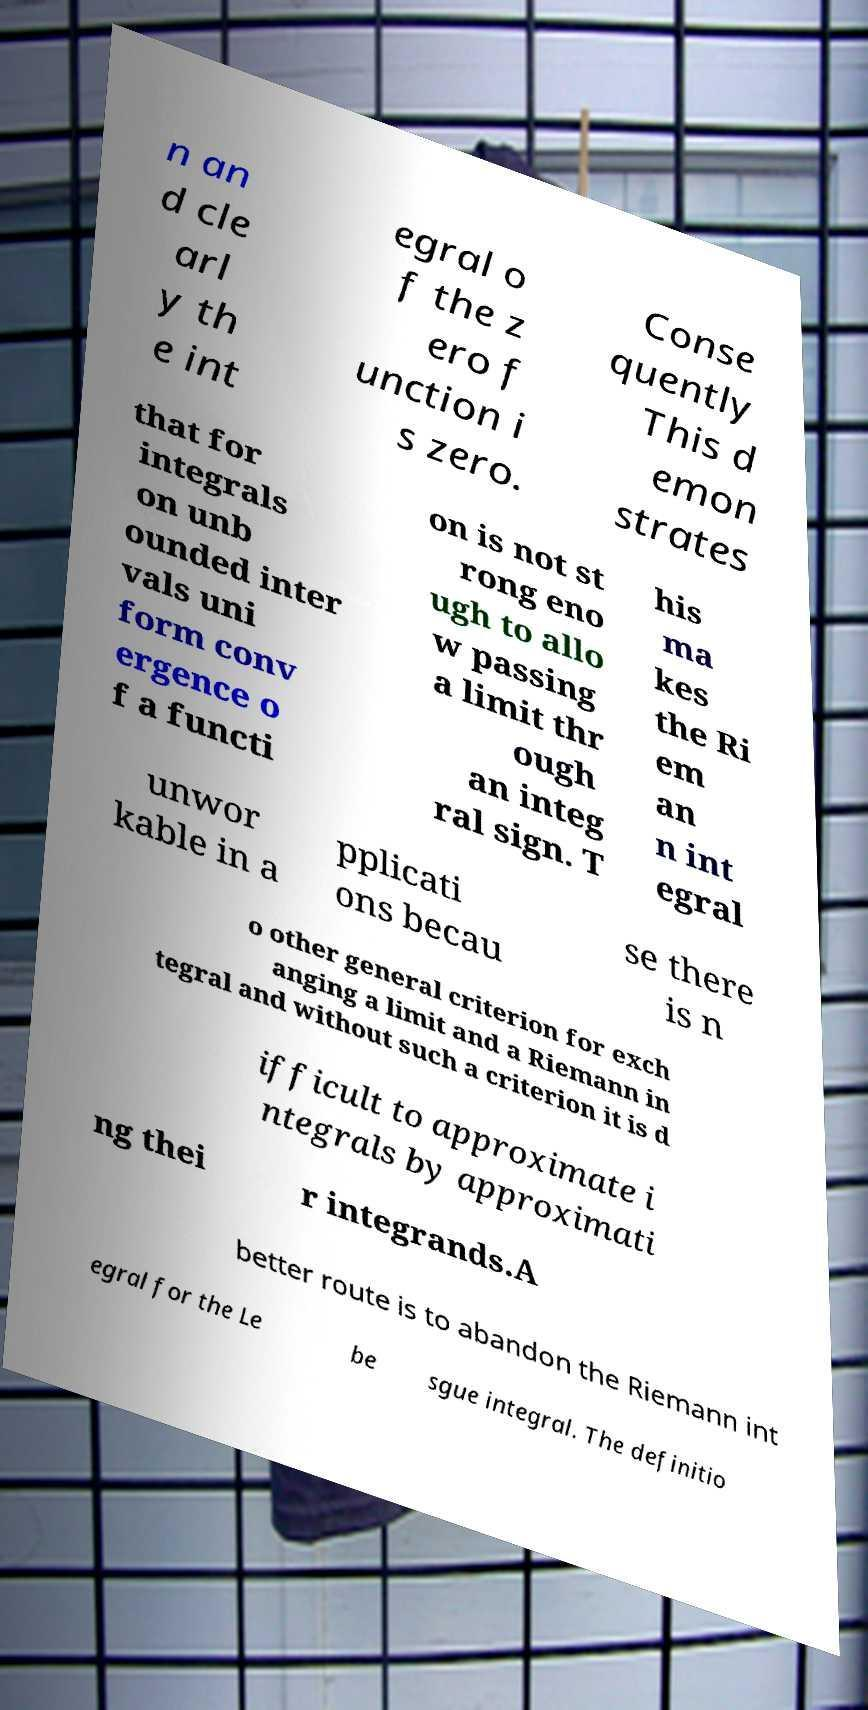For documentation purposes, I need the text within this image transcribed. Could you provide that? n an d cle arl y th e int egral o f the z ero f unction i s zero. Conse quently This d emon strates that for integrals on unb ounded inter vals uni form conv ergence o f a functi on is not st rong eno ugh to allo w passing a limit thr ough an integ ral sign. T his ma kes the Ri em an n int egral unwor kable in a pplicati ons becau se there is n o other general criterion for exch anging a limit and a Riemann in tegral and without such a criterion it is d ifficult to approximate i ntegrals by approximati ng thei r integrands.A better route is to abandon the Riemann int egral for the Le be sgue integral. The definitio 